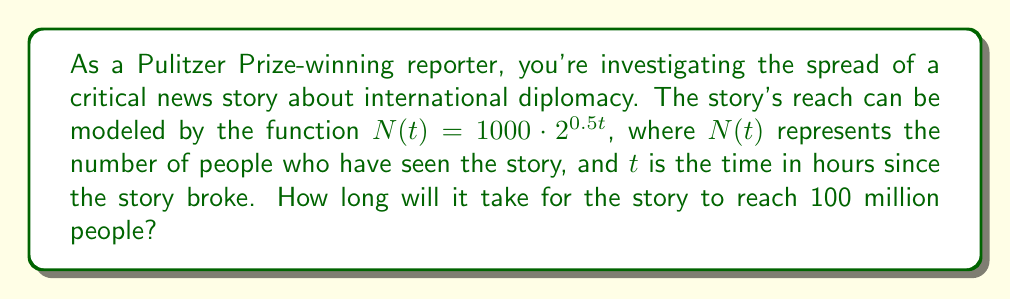Teach me how to tackle this problem. To solve this problem, we'll follow these steps:

1) We need to find $t$ when $N(t) = 100,000,000$ (100 million).

2) Let's set up the equation:
   $100,000,000 = 1000 \cdot 2^{0.5t}$

3) Divide both sides by 1000:
   $100,000 = 2^{0.5t}$

4) Take the logarithm (base 2) of both sides:
   $\log_2(100,000) = \log_2(2^{0.5t})$

5) Using the logarithm property $\log_a(a^x) = x$:
   $\log_2(100,000) = 0.5t$

6) Solve for $t$:
   $t = \frac{\log_2(100,000)}{0.5}$

7) Calculate:
   $t = \frac{\log_2(100,000)}{0.5} \approx 33.22$ hours

Therefore, it will take approximately 33.22 hours for the story to reach 100 million people.
Answer: $33.22$ hours 